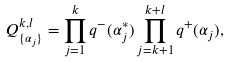Convert formula to latex. <formula><loc_0><loc_0><loc_500><loc_500>Q _ { \{ \alpha _ { j } \} } ^ { k , l } = \prod _ { j = 1 } ^ { k } q ^ { - } ( \alpha _ { j } ^ { * } ) \prod _ { j = k + 1 } ^ { k + l } q ^ { + } ( \alpha _ { j } ) ,</formula> 